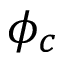Convert formula to latex. <formula><loc_0><loc_0><loc_500><loc_500>\phi _ { c }</formula> 